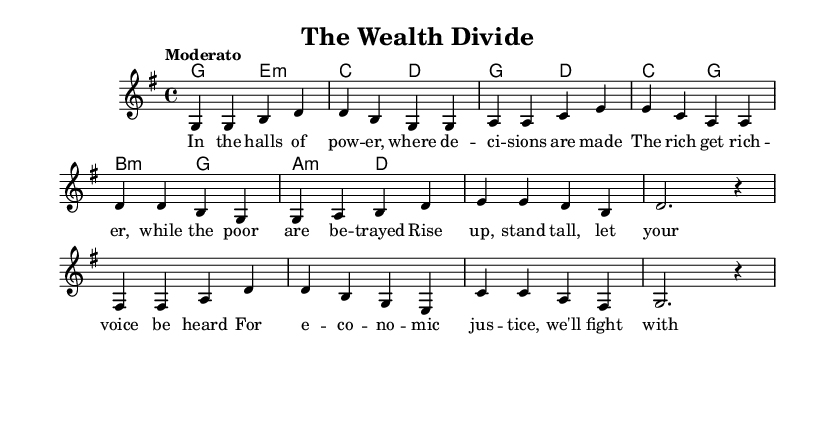What is the key signature of this music? The key signature indicated in the score is G major, which has one sharp (F#). You can determine this by looking at the key signature notation at the beginning of the staff.
Answer: G major What is the time signature of this music? The time signature shown in the score is 4/4, which means there are four beats in each measure and a quarter note receives one beat. This can be observed in the notation placed at the beginning of the staff.
Answer: 4/4 What is the tempo marking of the piece? The tempo marking at the beginning of the score is "Moderato," indicating a moderate speed for the piece. This can be identified in the tempo notation provided above the staff.
Answer: Moderato How many verses are present in this song? The song contains one verse as indicated in the lyric sections. The lyrics layout suggests a single verse followed by a chorus and bridge without repeating any verses.
Answer: One What message does the chorus convey regarding economic justice? The lyrics of the chorus emphasize rising up and standing tall to fight for economic justice, highlighting the importance of being vocal and active in advocating for fairness. This can be analyzed through the contents of the chorus section.
Answer: Fight for economic justice What musical role do the harmonies play in this folk song? The harmonies provide the chordal support for the melody, creating a fuller sound and emotional depth typical of folk songs. In this score, they enrich the storytelling aspect by complementing the vocal lines. This is seen in the chord mode section providing accompanying chords to each melody line.
Answer: Chordal support What theme is addressed in the bridge lyrics? The bridge lyrics address unity and equality, stressing the importance of standing together to achieve fairness for everyone. This theme is explicitly stated in the lyrics and aligns with the overarching message of the song concerning economic inequality.
Answer: Unity and equality 